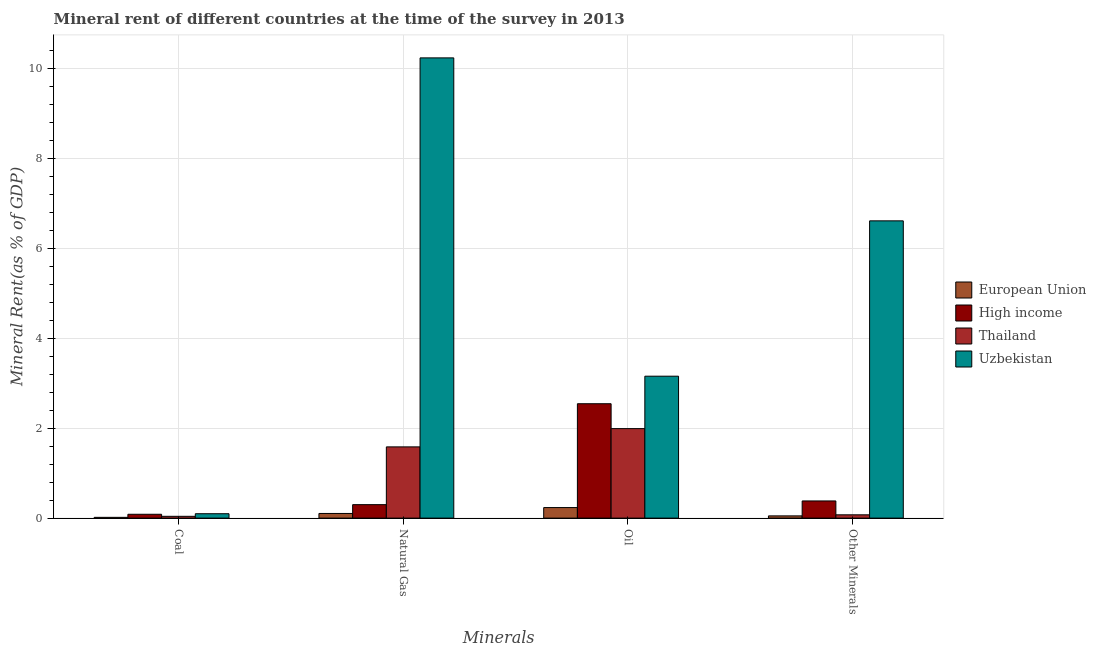How many groups of bars are there?
Your answer should be compact. 4. Are the number of bars per tick equal to the number of legend labels?
Your answer should be compact. Yes. How many bars are there on the 1st tick from the left?
Make the answer very short. 4. What is the label of the 4th group of bars from the left?
Your response must be concise. Other Minerals. What is the oil rent in Uzbekistan?
Offer a very short reply. 3.15. Across all countries, what is the maximum  rent of other minerals?
Keep it short and to the point. 6.61. Across all countries, what is the minimum natural gas rent?
Offer a terse response. 0.1. In which country was the coal rent maximum?
Ensure brevity in your answer.  Uzbekistan. What is the total coal rent in the graph?
Your response must be concise. 0.24. What is the difference between the oil rent in High income and that in Uzbekistan?
Offer a terse response. -0.61. What is the difference between the oil rent in European Union and the  rent of other minerals in High income?
Provide a succinct answer. -0.15. What is the average  rent of other minerals per country?
Make the answer very short. 1.78. What is the difference between the coal rent and natural gas rent in High income?
Provide a succinct answer. -0.21. What is the ratio of the  rent of other minerals in European Union to that in High income?
Your response must be concise. 0.13. Is the difference between the oil rent in Thailand and Uzbekistan greater than the difference between the natural gas rent in Thailand and Uzbekistan?
Provide a short and direct response. Yes. What is the difference between the highest and the second highest oil rent?
Offer a terse response. 0.61. What is the difference between the highest and the lowest oil rent?
Keep it short and to the point. 2.92. In how many countries, is the coal rent greater than the average coal rent taken over all countries?
Make the answer very short. 2. Is it the case that in every country, the sum of the coal rent and oil rent is greater than the sum of  rent of other minerals and natural gas rent?
Your response must be concise. No. What does the 3rd bar from the left in Oil represents?
Offer a terse response. Thailand. What does the 1st bar from the right in Oil represents?
Offer a terse response. Uzbekistan. Are all the bars in the graph horizontal?
Ensure brevity in your answer.  No. Are the values on the major ticks of Y-axis written in scientific E-notation?
Offer a very short reply. No. Where does the legend appear in the graph?
Your answer should be compact. Center right. How many legend labels are there?
Your answer should be compact. 4. What is the title of the graph?
Provide a succinct answer. Mineral rent of different countries at the time of the survey in 2013. Does "Lesotho" appear as one of the legend labels in the graph?
Keep it short and to the point. No. What is the label or title of the X-axis?
Keep it short and to the point. Minerals. What is the label or title of the Y-axis?
Offer a very short reply. Mineral Rent(as % of GDP). What is the Mineral Rent(as % of GDP) in European Union in Coal?
Offer a terse response. 0.02. What is the Mineral Rent(as % of GDP) in High income in Coal?
Your response must be concise. 0.09. What is the Mineral Rent(as % of GDP) in Thailand in Coal?
Make the answer very short. 0.04. What is the Mineral Rent(as % of GDP) of Uzbekistan in Coal?
Your answer should be very brief. 0.1. What is the Mineral Rent(as % of GDP) in European Union in Natural Gas?
Ensure brevity in your answer.  0.1. What is the Mineral Rent(as % of GDP) of High income in Natural Gas?
Offer a terse response. 0.3. What is the Mineral Rent(as % of GDP) in Thailand in Natural Gas?
Your answer should be very brief. 1.58. What is the Mineral Rent(as % of GDP) of Uzbekistan in Natural Gas?
Offer a terse response. 10.23. What is the Mineral Rent(as % of GDP) in European Union in Oil?
Ensure brevity in your answer.  0.23. What is the Mineral Rent(as % of GDP) in High income in Oil?
Make the answer very short. 2.54. What is the Mineral Rent(as % of GDP) of Thailand in Oil?
Your answer should be very brief. 1.99. What is the Mineral Rent(as % of GDP) in Uzbekistan in Oil?
Your answer should be very brief. 3.15. What is the Mineral Rent(as % of GDP) in European Union in Other Minerals?
Offer a terse response. 0.05. What is the Mineral Rent(as % of GDP) in High income in Other Minerals?
Provide a short and direct response. 0.38. What is the Mineral Rent(as % of GDP) of Thailand in Other Minerals?
Provide a short and direct response. 0.07. What is the Mineral Rent(as % of GDP) in Uzbekistan in Other Minerals?
Your answer should be compact. 6.61. Across all Minerals, what is the maximum Mineral Rent(as % of GDP) of European Union?
Offer a terse response. 0.23. Across all Minerals, what is the maximum Mineral Rent(as % of GDP) in High income?
Give a very brief answer. 2.54. Across all Minerals, what is the maximum Mineral Rent(as % of GDP) in Thailand?
Provide a succinct answer. 1.99. Across all Minerals, what is the maximum Mineral Rent(as % of GDP) of Uzbekistan?
Your answer should be very brief. 10.23. Across all Minerals, what is the minimum Mineral Rent(as % of GDP) in European Union?
Your answer should be compact. 0.02. Across all Minerals, what is the minimum Mineral Rent(as % of GDP) of High income?
Your response must be concise. 0.09. Across all Minerals, what is the minimum Mineral Rent(as % of GDP) of Thailand?
Ensure brevity in your answer.  0.04. Across all Minerals, what is the minimum Mineral Rent(as % of GDP) in Uzbekistan?
Your answer should be compact. 0.1. What is the total Mineral Rent(as % of GDP) in European Union in the graph?
Ensure brevity in your answer.  0.4. What is the total Mineral Rent(as % of GDP) of High income in the graph?
Offer a very short reply. 3.31. What is the total Mineral Rent(as % of GDP) of Thailand in the graph?
Make the answer very short. 3.69. What is the total Mineral Rent(as % of GDP) in Uzbekistan in the graph?
Keep it short and to the point. 20.09. What is the difference between the Mineral Rent(as % of GDP) of European Union in Coal and that in Natural Gas?
Your answer should be very brief. -0.09. What is the difference between the Mineral Rent(as % of GDP) of High income in Coal and that in Natural Gas?
Make the answer very short. -0.21. What is the difference between the Mineral Rent(as % of GDP) in Thailand in Coal and that in Natural Gas?
Give a very brief answer. -1.54. What is the difference between the Mineral Rent(as % of GDP) in Uzbekistan in Coal and that in Natural Gas?
Provide a short and direct response. -10.13. What is the difference between the Mineral Rent(as % of GDP) in European Union in Coal and that in Oil?
Make the answer very short. -0.22. What is the difference between the Mineral Rent(as % of GDP) of High income in Coal and that in Oil?
Your response must be concise. -2.46. What is the difference between the Mineral Rent(as % of GDP) in Thailand in Coal and that in Oil?
Your answer should be compact. -1.95. What is the difference between the Mineral Rent(as % of GDP) in Uzbekistan in Coal and that in Oil?
Make the answer very short. -3.06. What is the difference between the Mineral Rent(as % of GDP) in European Union in Coal and that in Other Minerals?
Your answer should be compact. -0.03. What is the difference between the Mineral Rent(as % of GDP) of High income in Coal and that in Other Minerals?
Offer a terse response. -0.3. What is the difference between the Mineral Rent(as % of GDP) of Thailand in Coal and that in Other Minerals?
Keep it short and to the point. -0.03. What is the difference between the Mineral Rent(as % of GDP) in Uzbekistan in Coal and that in Other Minerals?
Keep it short and to the point. -6.51. What is the difference between the Mineral Rent(as % of GDP) in European Union in Natural Gas and that in Oil?
Your response must be concise. -0.13. What is the difference between the Mineral Rent(as % of GDP) of High income in Natural Gas and that in Oil?
Keep it short and to the point. -2.24. What is the difference between the Mineral Rent(as % of GDP) of Thailand in Natural Gas and that in Oil?
Offer a terse response. -0.41. What is the difference between the Mineral Rent(as % of GDP) of Uzbekistan in Natural Gas and that in Oil?
Make the answer very short. 7.08. What is the difference between the Mineral Rent(as % of GDP) in European Union in Natural Gas and that in Other Minerals?
Ensure brevity in your answer.  0.05. What is the difference between the Mineral Rent(as % of GDP) of High income in Natural Gas and that in Other Minerals?
Offer a terse response. -0.08. What is the difference between the Mineral Rent(as % of GDP) of Thailand in Natural Gas and that in Other Minerals?
Ensure brevity in your answer.  1.51. What is the difference between the Mineral Rent(as % of GDP) of Uzbekistan in Natural Gas and that in Other Minerals?
Offer a very short reply. 3.62. What is the difference between the Mineral Rent(as % of GDP) of European Union in Oil and that in Other Minerals?
Offer a very short reply. 0.18. What is the difference between the Mineral Rent(as % of GDP) in High income in Oil and that in Other Minerals?
Your answer should be compact. 2.16. What is the difference between the Mineral Rent(as % of GDP) of Thailand in Oil and that in Other Minerals?
Give a very brief answer. 1.92. What is the difference between the Mineral Rent(as % of GDP) of Uzbekistan in Oil and that in Other Minerals?
Keep it short and to the point. -3.45. What is the difference between the Mineral Rent(as % of GDP) of European Union in Coal and the Mineral Rent(as % of GDP) of High income in Natural Gas?
Keep it short and to the point. -0.28. What is the difference between the Mineral Rent(as % of GDP) of European Union in Coal and the Mineral Rent(as % of GDP) of Thailand in Natural Gas?
Ensure brevity in your answer.  -1.57. What is the difference between the Mineral Rent(as % of GDP) in European Union in Coal and the Mineral Rent(as % of GDP) in Uzbekistan in Natural Gas?
Ensure brevity in your answer.  -10.21. What is the difference between the Mineral Rent(as % of GDP) in High income in Coal and the Mineral Rent(as % of GDP) in Thailand in Natural Gas?
Your response must be concise. -1.5. What is the difference between the Mineral Rent(as % of GDP) of High income in Coal and the Mineral Rent(as % of GDP) of Uzbekistan in Natural Gas?
Your answer should be very brief. -10.14. What is the difference between the Mineral Rent(as % of GDP) of Thailand in Coal and the Mineral Rent(as % of GDP) of Uzbekistan in Natural Gas?
Ensure brevity in your answer.  -10.19. What is the difference between the Mineral Rent(as % of GDP) of European Union in Coal and the Mineral Rent(as % of GDP) of High income in Oil?
Offer a very short reply. -2.53. What is the difference between the Mineral Rent(as % of GDP) of European Union in Coal and the Mineral Rent(as % of GDP) of Thailand in Oil?
Provide a succinct answer. -1.97. What is the difference between the Mineral Rent(as % of GDP) of European Union in Coal and the Mineral Rent(as % of GDP) of Uzbekistan in Oil?
Give a very brief answer. -3.14. What is the difference between the Mineral Rent(as % of GDP) in High income in Coal and the Mineral Rent(as % of GDP) in Thailand in Oil?
Ensure brevity in your answer.  -1.9. What is the difference between the Mineral Rent(as % of GDP) in High income in Coal and the Mineral Rent(as % of GDP) in Uzbekistan in Oil?
Your response must be concise. -3.07. What is the difference between the Mineral Rent(as % of GDP) in Thailand in Coal and the Mineral Rent(as % of GDP) in Uzbekistan in Oil?
Your response must be concise. -3.11. What is the difference between the Mineral Rent(as % of GDP) in European Union in Coal and the Mineral Rent(as % of GDP) in High income in Other Minerals?
Offer a very short reply. -0.36. What is the difference between the Mineral Rent(as % of GDP) in European Union in Coal and the Mineral Rent(as % of GDP) in Thailand in Other Minerals?
Make the answer very short. -0.06. What is the difference between the Mineral Rent(as % of GDP) of European Union in Coal and the Mineral Rent(as % of GDP) of Uzbekistan in Other Minerals?
Ensure brevity in your answer.  -6.59. What is the difference between the Mineral Rent(as % of GDP) of High income in Coal and the Mineral Rent(as % of GDP) of Thailand in Other Minerals?
Your answer should be compact. 0.01. What is the difference between the Mineral Rent(as % of GDP) in High income in Coal and the Mineral Rent(as % of GDP) in Uzbekistan in Other Minerals?
Your response must be concise. -6.52. What is the difference between the Mineral Rent(as % of GDP) of Thailand in Coal and the Mineral Rent(as % of GDP) of Uzbekistan in Other Minerals?
Offer a very short reply. -6.57. What is the difference between the Mineral Rent(as % of GDP) of European Union in Natural Gas and the Mineral Rent(as % of GDP) of High income in Oil?
Give a very brief answer. -2.44. What is the difference between the Mineral Rent(as % of GDP) of European Union in Natural Gas and the Mineral Rent(as % of GDP) of Thailand in Oil?
Offer a very short reply. -1.89. What is the difference between the Mineral Rent(as % of GDP) in European Union in Natural Gas and the Mineral Rent(as % of GDP) in Uzbekistan in Oil?
Provide a succinct answer. -3.05. What is the difference between the Mineral Rent(as % of GDP) in High income in Natural Gas and the Mineral Rent(as % of GDP) in Thailand in Oil?
Offer a terse response. -1.69. What is the difference between the Mineral Rent(as % of GDP) of High income in Natural Gas and the Mineral Rent(as % of GDP) of Uzbekistan in Oil?
Your response must be concise. -2.85. What is the difference between the Mineral Rent(as % of GDP) of Thailand in Natural Gas and the Mineral Rent(as % of GDP) of Uzbekistan in Oil?
Your response must be concise. -1.57. What is the difference between the Mineral Rent(as % of GDP) of European Union in Natural Gas and the Mineral Rent(as % of GDP) of High income in Other Minerals?
Make the answer very short. -0.28. What is the difference between the Mineral Rent(as % of GDP) of European Union in Natural Gas and the Mineral Rent(as % of GDP) of Thailand in Other Minerals?
Your answer should be compact. 0.03. What is the difference between the Mineral Rent(as % of GDP) in European Union in Natural Gas and the Mineral Rent(as % of GDP) in Uzbekistan in Other Minerals?
Your answer should be compact. -6.5. What is the difference between the Mineral Rent(as % of GDP) in High income in Natural Gas and the Mineral Rent(as % of GDP) in Thailand in Other Minerals?
Your answer should be very brief. 0.23. What is the difference between the Mineral Rent(as % of GDP) of High income in Natural Gas and the Mineral Rent(as % of GDP) of Uzbekistan in Other Minerals?
Your answer should be compact. -6.31. What is the difference between the Mineral Rent(as % of GDP) in Thailand in Natural Gas and the Mineral Rent(as % of GDP) in Uzbekistan in Other Minerals?
Ensure brevity in your answer.  -5.02. What is the difference between the Mineral Rent(as % of GDP) of European Union in Oil and the Mineral Rent(as % of GDP) of High income in Other Minerals?
Keep it short and to the point. -0.15. What is the difference between the Mineral Rent(as % of GDP) of European Union in Oil and the Mineral Rent(as % of GDP) of Thailand in Other Minerals?
Provide a short and direct response. 0.16. What is the difference between the Mineral Rent(as % of GDP) of European Union in Oil and the Mineral Rent(as % of GDP) of Uzbekistan in Other Minerals?
Ensure brevity in your answer.  -6.37. What is the difference between the Mineral Rent(as % of GDP) in High income in Oil and the Mineral Rent(as % of GDP) in Thailand in Other Minerals?
Give a very brief answer. 2.47. What is the difference between the Mineral Rent(as % of GDP) of High income in Oil and the Mineral Rent(as % of GDP) of Uzbekistan in Other Minerals?
Make the answer very short. -4.06. What is the difference between the Mineral Rent(as % of GDP) in Thailand in Oil and the Mineral Rent(as % of GDP) in Uzbekistan in Other Minerals?
Keep it short and to the point. -4.62. What is the average Mineral Rent(as % of GDP) of European Union per Minerals?
Ensure brevity in your answer.  0.1. What is the average Mineral Rent(as % of GDP) in High income per Minerals?
Your answer should be very brief. 0.83. What is the average Mineral Rent(as % of GDP) in Thailand per Minerals?
Offer a terse response. 0.92. What is the average Mineral Rent(as % of GDP) in Uzbekistan per Minerals?
Provide a succinct answer. 5.02. What is the difference between the Mineral Rent(as % of GDP) in European Union and Mineral Rent(as % of GDP) in High income in Coal?
Offer a terse response. -0.07. What is the difference between the Mineral Rent(as % of GDP) of European Union and Mineral Rent(as % of GDP) of Thailand in Coal?
Ensure brevity in your answer.  -0.02. What is the difference between the Mineral Rent(as % of GDP) in European Union and Mineral Rent(as % of GDP) in Uzbekistan in Coal?
Make the answer very short. -0.08. What is the difference between the Mineral Rent(as % of GDP) in High income and Mineral Rent(as % of GDP) in Thailand in Coal?
Provide a succinct answer. 0.05. What is the difference between the Mineral Rent(as % of GDP) of High income and Mineral Rent(as % of GDP) of Uzbekistan in Coal?
Provide a succinct answer. -0.01. What is the difference between the Mineral Rent(as % of GDP) of Thailand and Mineral Rent(as % of GDP) of Uzbekistan in Coal?
Provide a short and direct response. -0.06. What is the difference between the Mineral Rent(as % of GDP) of European Union and Mineral Rent(as % of GDP) of High income in Natural Gas?
Give a very brief answer. -0.2. What is the difference between the Mineral Rent(as % of GDP) of European Union and Mineral Rent(as % of GDP) of Thailand in Natural Gas?
Offer a terse response. -1.48. What is the difference between the Mineral Rent(as % of GDP) in European Union and Mineral Rent(as % of GDP) in Uzbekistan in Natural Gas?
Provide a succinct answer. -10.13. What is the difference between the Mineral Rent(as % of GDP) of High income and Mineral Rent(as % of GDP) of Thailand in Natural Gas?
Provide a succinct answer. -1.28. What is the difference between the Mineral Rent(as % of GDP) in High income and Mineral Rent(as % of GDP) in Uzbekistan in Natural Gas?
Your answer should be compact. -9.93. What is the difference between the Mineral Rent(as % of GDP) in Thailand and Mineral Rent(as % of GDP) in Uzbekistan in Natural Gas?
Provide a short and direct response. -8.65. What is the difference between the Mineral Rent(as % of GDP) of European Union and Mineral Rent(as % of GDP) of High income in Oil?
Offer a very short reply. -2.31. What is the difference between the Mineral Rent(as % of GDP) of European Union and Mineral Rent(as % of GDP) of Thailand in Oil?
Ensure brevity in your answer.  -1.75. What is the difference between the Mineral Rent(as % of GDP) in European Union and Mineral Rent(as % of GDP) in Uzbekistan in Oil?
Your response must be concise. -2.92. What is the difference between the Mineral Rent(as % of GDP) of High income and Mineral Rent(as % of GDP) of Thailand in Oil?
Offer a very short reply. 0.55. What is the difference between the Mineral Rent(as % of GDP) in High income and Mineral Rent(as % of GDP) in Uzbekistan in Oil?
Provide a short and direct response. -0.61. What is the difference between the Mineral Rent(as % of GDP) in Thailand and Mineral Rent(as % of GDP) in Uzbekistan in Oil?
Ensure brevity in your answer.  -1.17. What is the difference between the Mineral Rent(as % of GDP) in European Union and Mineral Rent(as % of GDP) in High income in Other Minerals?
Provide a succinct answer. -0.33. What is the difference between the Mineral Rent(as % of GDP) of European Union and Mineral Rent(as % of GDP) of Thailand in Other Minerals?
Keep it short and to the point. -0.02. What is the difference between the Mineral Rent(as % of GDP) of European Union and Mineral Rent(as % of GDP) of Uzbekistan in Other Minerals?
Your response must be concise. -6.56. What is the difference between the Mineral Rent(as % of GDP) in High income and Mineral Rent(as % of GDP) in Thailand in Other Minerals?
Keep it short and to the point. 0.31. What is the difference between the Mineral Rent(as % of GDP) in High income and Mineral Rent(as % of GDP) in Uzbekistan in Other Minerals?
Provide a succinct answer. -6.23. What is the difference between the Mineral Rent(as % of GDP) in Thailand and Mineral Rent(as % of GDP) in Uzbekistan in Other Minerals?
Your response must be concise. -6.53. What is the ratio of the Mineral Rent(as % of GDP) of European Union in Coal to that in Natural Gas?
Your answer should be very brief. 0.16. What is the ratio of the Mineral Rent(as % of GDP) of High income in Coal to that in Natural Gas?
Give a very brief answer. 0.29. What is the ratio of the Mineral Rent(as % of GDP) of Thailand in Coal to that in Natural Gas?
Your answer should be compact. 0.03. What is the ratio of the Mineral Rent(as % of GDP) of Uzbekistan in Coal to that in Natural Gas?
Make the answer very short. 0.01. What is the ratio of the Mineral Rent(as % of GDP) in European Union in Coal to that in Oil?
Your response must be concise. 0.07. What is the ratio of the Mineral Rent(as % of GDP) of High income in Coal to that in Oil?
Offer a terse response. 0.03. What is the ratio of the Mineral Rent(as % of GDP) of Thailand in Coal to that in Oil?
Keep it short and to the point. 0.02. What is the ratio of the Mineral Rent(as % of GDP) of Uzbekistan in Coal to that in Oil?
Make the answer very short. 0.03. What is the ratio of the Mineral Rent(as % of GDP) in European Union in Coal to that in Other Minerals?
Provide a succinct answer. 0.34. What is the ratio of the Mineral Rent(as % of GDP) of High income in Coal to that in Other Minerals?
Offer a very short reply. 0.22. What is the ratio of the Mineral Rent(as % of GDP) of Thailand in Coal to that in Other Minerals?
Offer a terse response. 0.54. What is the ratio of the Mineral Rent(as % of GDP) of Uzbekistan in Coal to that in Other Minerals?
Your response must be concise. 0.01. What is the ratio of the Mineral Rent(as % of GDP) of European Union in Natural Gas to that in Oil?
Your response must be concise. 0.44. What is the ratio of the Mineral Rent(as % of GDP) in High income in Natural Gas to that in Oil?
Offer a terse response. 0.12. What is the ratio of the Mineral Rent(as % of GDP) in Thailand in Natural Gas to that in Oil?
Provide a short and direct response. 0.8. What is the ratio of the Mineral Rent(as % of GDP) of Uzbekistan in Natural Gas to that in Oil?
Ensure brevity in your answer.  3.24. What is the ratio of the Mineral Rent(as % of GDP) in European Union in Natural Gas to that in Other Minerals?
Your answer should be very brief. 2.09. What is the ratio of the Mineral Rent(as % of GDP) in High income in Natural Gas to that in Other Minerals?
Offer a terse response. 0.78. What is the ratio of the Mineral Rent(as % of GDP) in Thailand in Natural Gas to that in Other Minerals?
Your answer should be compact. 21.61. What is the ratio of the Mineral Rent(as % of GDP) of Uzbekistan in Natural Gas to that in Other Minerals?
Your answer should be compact. 1.55. What is the ratio of the Mineral Rent(as % of GDP) of European Union in Oil to that in Other Minerals?
Provide a succinct answer. 4.72. What is the ratio of the Mineral Rent(as % of GDP) in High income in Oil to that in Other Minerals?
Your response must be concise. 6.66. What is the ratio of the Mineral Rent(as % of GDP) of Thailand in Oil to that in Other Minerals?
Your response must be concise. 27.15. What is the ratio of the Mineral Rent(as % of GDP) in Uzbekistan in Oil to that in Other Minerals?
Give a very brief answer. 0.48. What is the difference between the highest and the second highest Mineral Rent(as % of GDP) in European Union?
Ensure brevity in your answer.  0.13. What is the difference between the highest and the second highest Mineral Rent(as % of GDP) in High income?
Make the answer very short. 2.16. What is the difference between the highest and the second highest Mineral Rent(as % of GDP) in Thailand?
Give a very brief answer. 0.41. What is the difference between the highest and the second highest Mineral Rent(as % of GDP) of Uzbekistan?
Offer a very short reply. 3.62. What is the difference between the highest and the lowest Mineral Rent(as % of GDP) of European Union?
Provide a short and direct response. 0.22. What is the difference between the highest and the lowest Mineral Rent(as % of GDP) in High income?
Provide a succinct answer. 2.46. What is the difference between the highest and the lowest Mineral Rent(as % of GDP) of Thailand?
Your answer should be compact. 1.95. What is the difference between the highest and the lowest Mineral Rent(as % of GDP) of Uzbekistan?
Your answer should be very brief. 10.13. 